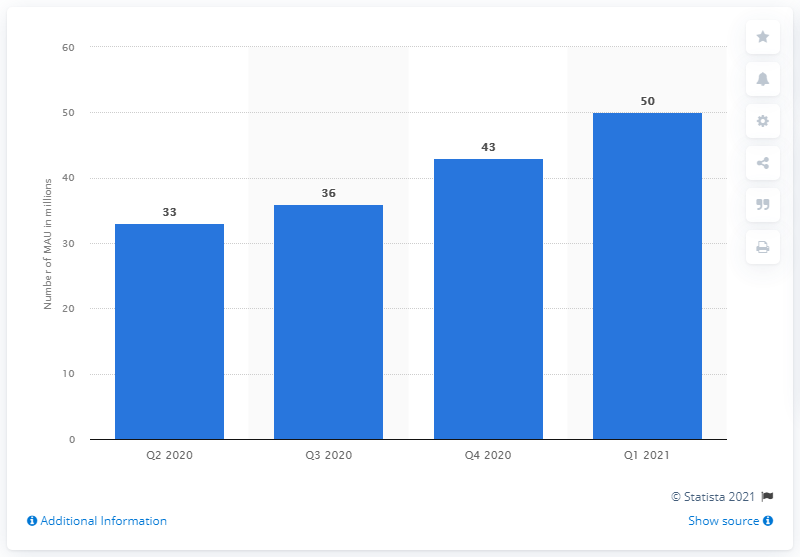Highlight a few significant elements in this photo. Pluto TV had 50 more users in the first quarter of 2021 than in the previous quarter. Pluto TV had approximately 50 monthly active users as of [insert date]. 